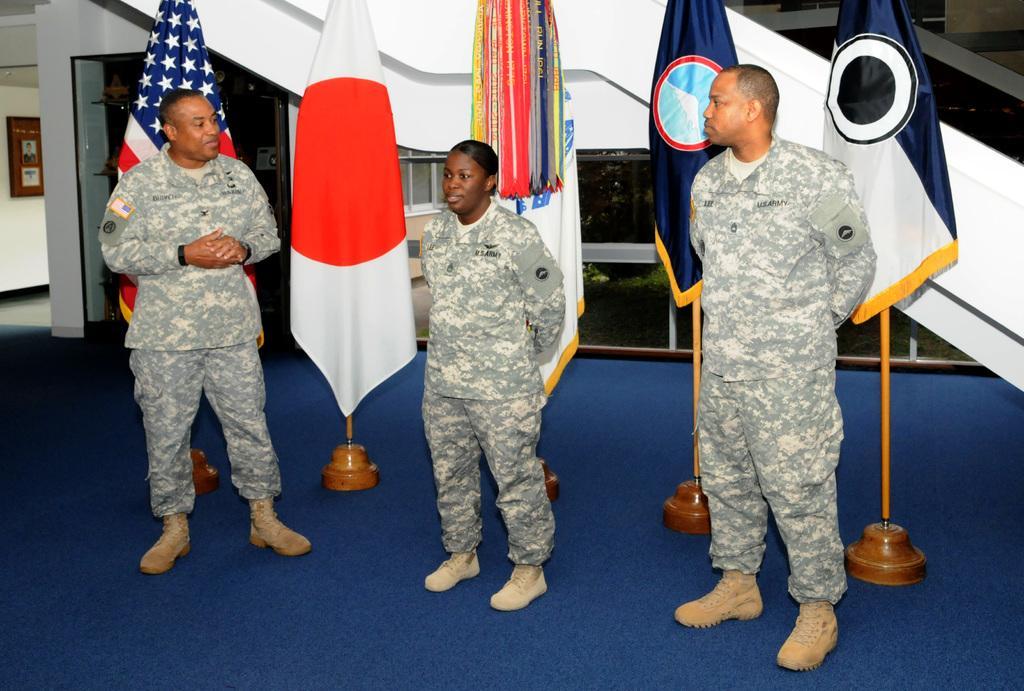Describe this image in one or two sentences. In this image in the foreground we can see three people standing and at the back we can see some flag. 